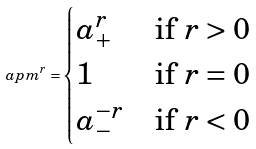Convert formula to latex. <formula><loc_0><loc_0><loc_500><loc_500>\ a p m ^ { r } = \begin{cases} a _ { + } ^ { r } & \text {if $r>0$} \\ 1 & \text {if $r=0$} \\ a _ { - } ^ { - r } & \text {if $r<0$} \end{cases}</formula> 